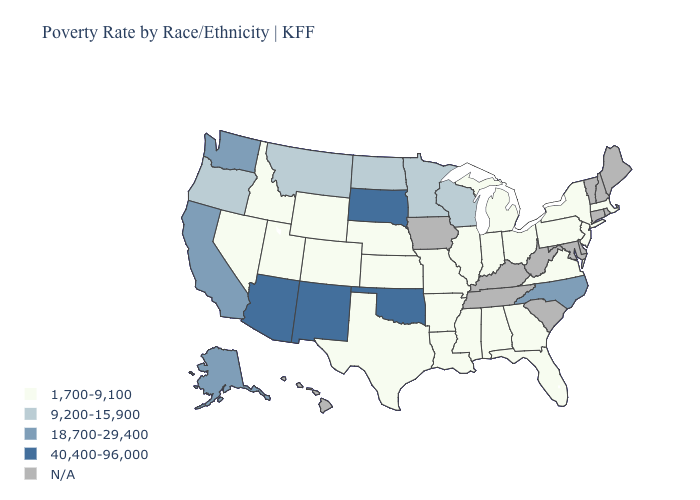Among the states that border Oregon , does Washington have the highest value?
Answer briefly. Yes. What is the value of Illinois?
Keep it brief. 1,700-9,100. Does New Mexico have the highest value in the USA?
Short answer required. Yes. What is the highest value in the USA?
Be succinct. 40,400-96,000. Name the states that have a value in the range N/A?
Concise answer only. Connecticut, Delaware, Hawaii, Iowa, Kentucky, Maine, Maryland, New Hampshire, Rhode Island, South Carolina, Tennessee, Vermont, West Virginia. What is the value of Arkansas?
Short answer required. 1,700-9,100. Does the map have missing data?
Write a very short answer. Yes. Which states hav the highest value in the West?
Keep it brief. Arizona, New Mexico. Name the states that have a value in the range 40,400-96,000?
Keep it brief. Arizona, New Mexico, Oklahoma, South Dakota. Name the states that have a value in the range N/A?
Be succinct. Connecticut, Delaware, Hawaii, Iowa, Kentucky, Maine, Maryland, New Hampshire, Rhode Island, South Carolina, Tennessee, Vermont, West Virginia. What is the value of Illinois?
Keep it brief. 1,700-9,100. Which states have the lowest value in the MidWest?
Write a very short answer. Illinois, Indiana, Kansas, Michigan, Missouri, Nebraska, Ohio. Does North Dakota have the lowest value in the MidWest?
Short answer required. No. 